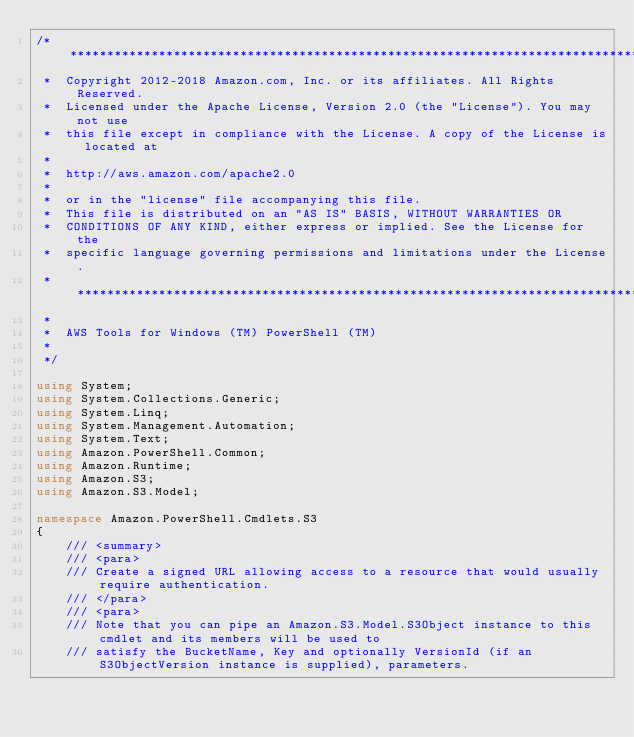Convert code to text. <code><loc_0><loc_0><loc_500><loc_500><_C#_>/*******************************************************************************
 *  Copyright 2012-2018 Amazon.com, Inc. or its affiliates. All Rights Reserved.
 *  Licensed under the Apache License, Version 2.0 (the "License"). You may not use
 *  this file except in compliance with the License. A copy of the License is located at
 *
 *  http://aws.amazon.com/apache2.0
 *
 *  or in the "license" file accompanying this file.
 *  This file is distributed on an "AS IS" BASIS, WITHOUT WARRANTIES OR
 *  CONDITIONS OF ANY KIND, either express or implied. See the License for the
 *  specific language governing permissions and limitations under the License.
 * *****************************************************************************
 *
 *  AWS Tools for Windows (TM) PowerShell (TM)
 *
 */

using System;
using System.Collections.Generic;
using System.Linq;
using System.Management.Automation;
using System.Text;
using Amazon.PowerShell.Common;
using Amazon.Runtime;
using Amazon.S3;
using Amazon.S3.Model;

namespace Amazon.PowerShell.Cmdlets.S3
{
    /// <summary>
    /// <para>
    /// Create a signed URL allowing access to a resource that would usually require authentication.
    /// </para>
    /// <para>
    /// Note that you can pipe an Amazon.S3.Model.S3Object instance to this cmdlet and its members will be used to
    /// satisfy the BucketName, Key and optionally VersionId (if an S3ObjectVersion instance is supplied), parameters.</code> 